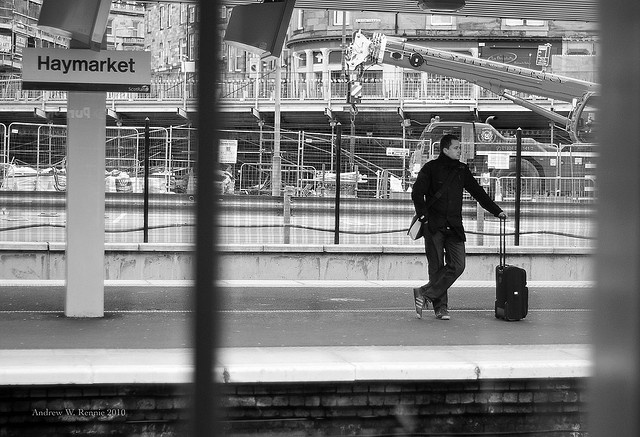Describe the objects in this image and their specific colors. I can see truck in gray, darkgray, lightgray, and black tones, people in gray, black, darkgray, and lightgray tones, suitcase in gray, black, lightgray, and darkgray tones, and handbag in gray, black, darkgray, and lightgray tones in this image. 